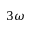<formula> <loc_0><loc_0><loc_500><loc_500>3 \omega</formula> 